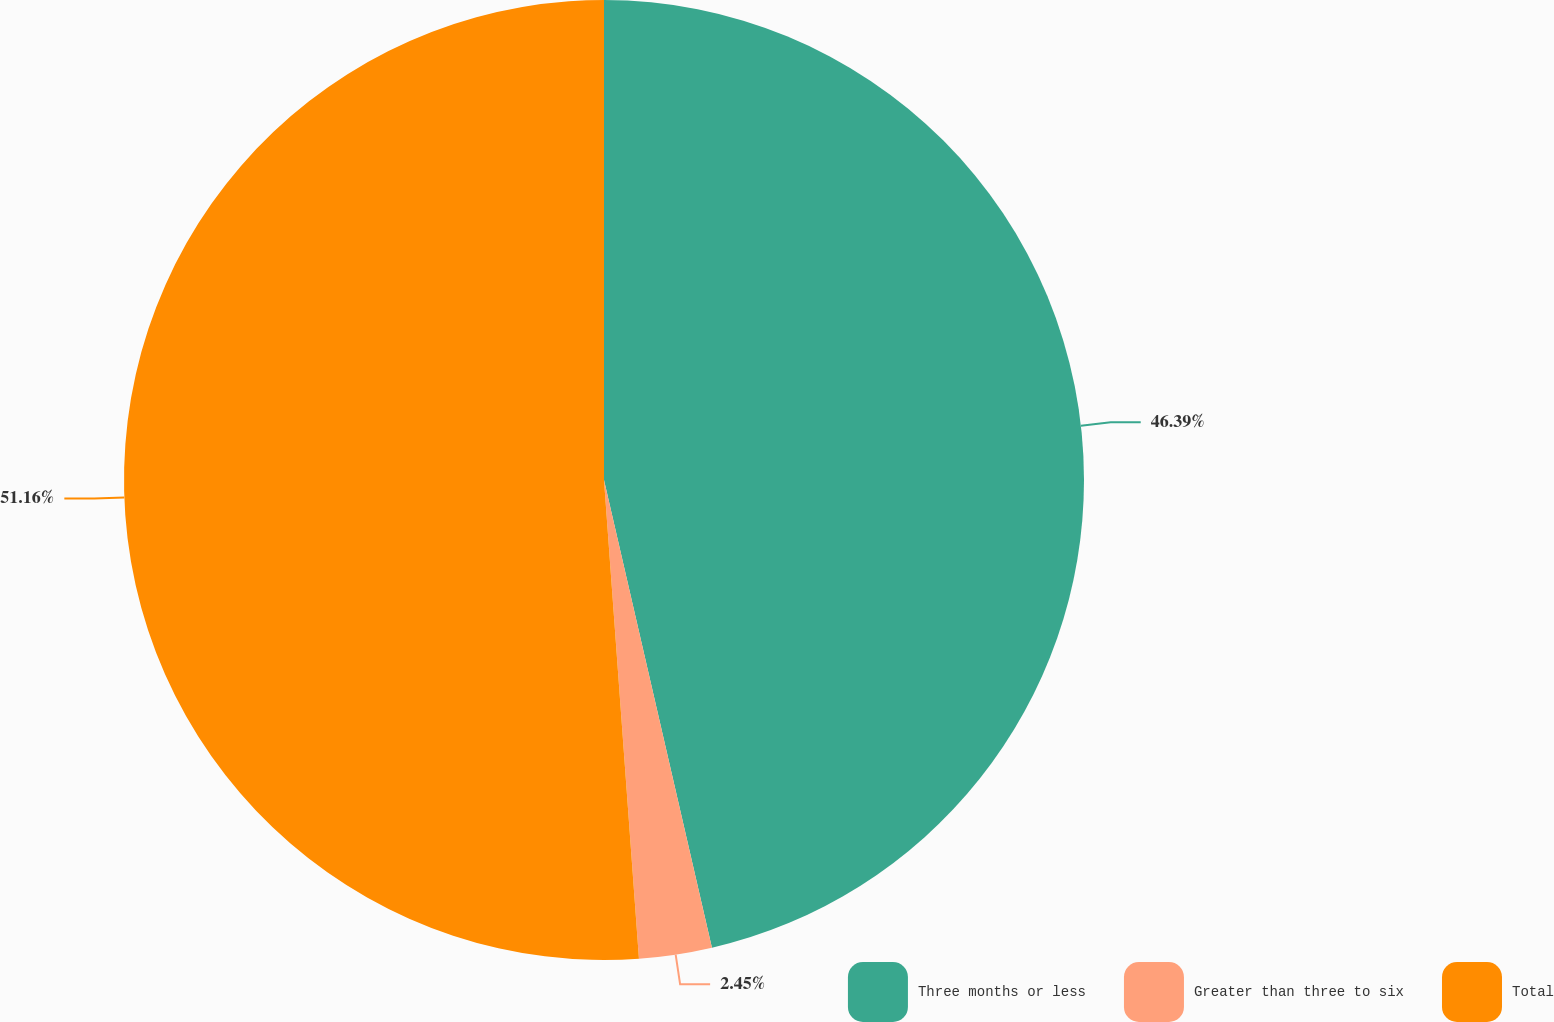<chart> <loc_0><loc_0><loc_500><loc_500><pie_chart><fcel>Three months or less<fcel>Greater than three to six<fcel>Total<nl><fcel>46.39%<fcel>2.45%<fcel>51.16%<nl></chart> 